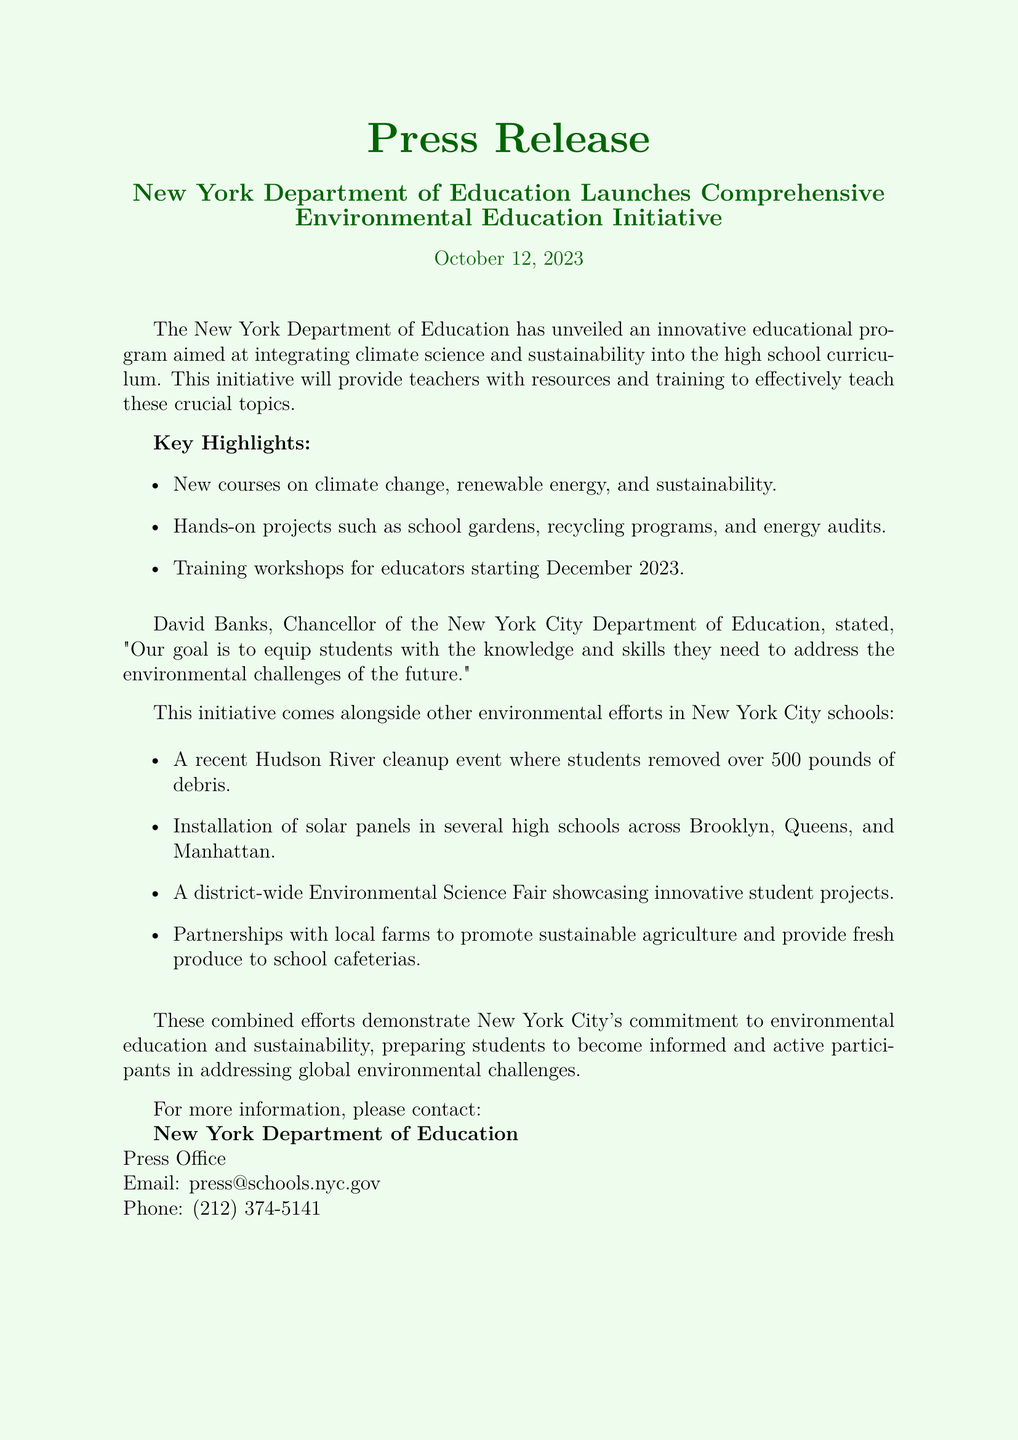What is the launch date of the environmental education program? The launch date is explicitly stated in the document as October 12, 2023.
Answer: October 12, 2023 How many pounds of debris were removed during the Hudson River cleanup? The document provides the specific amount of debris collected, which is mentioned as over 500 pounds.
Answer: Over 500 pounds What are the new course topics introduced in the educational program? The document lists the course topics, which include climate change, renewable energy, and sustainability.
Answer: Climate change, renewable energy, sustainability Who is the Chancellor of the New York City Department of Education? The document names David Banks as the Chancellor.
Answer: David Banks What initiative involves hands-on projects for students? The document describes the new environmental education program that includes hands-on projects like school gardens and recycling programs.
Answer: Environmental education program When will training workshops for educators start? The document mentions that the training workshops will begin in December 2023.
Answer: December 2023 What is the purpose of the partnership with local farms? The document states that the partnership aims to promote sustainable agriculture and provide fresh produce to school cafeterias.
Answer: Promote sustainable agriculture How many high schools are adopting solar energy solutions? The document indicates that multiple high schools are adopting solar energy solutions, but does not provide a specific number.
Answer: Multiple high schools 